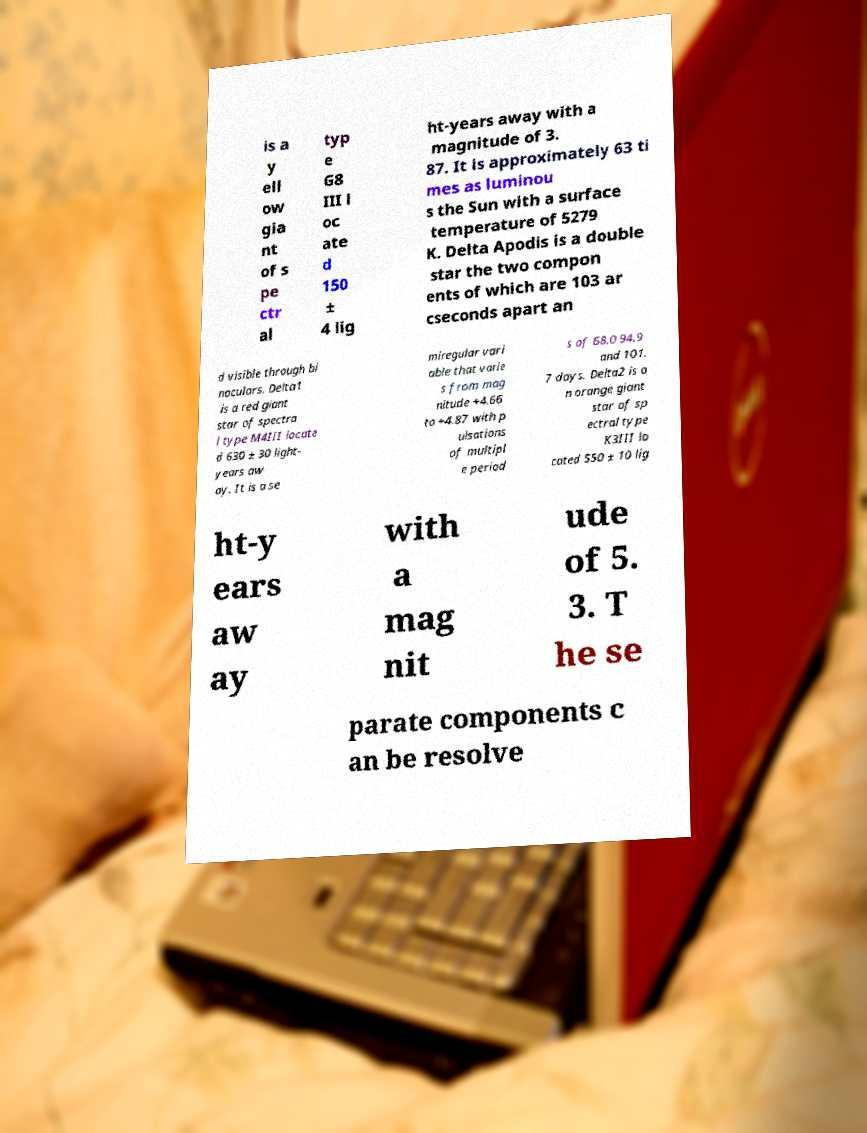There's text embedded in this image that I need extracted. Can you transcribe it verbatim? is a y ell ow gia nt of s pe ctr al typ e G8 III l oc ate d 150 ± 4 lig ht-years away with a magnitude of 3. 87. It is approximately 63 ti mes as luminou s the Sun with a surface temperature of 5279 K. Delta Apodis is a double star the two compon ents of which are 103 ar cseconds apart an d visible through bi noculars. Delta1 is a red giant star of spectra l type M4III locate d 630 ± 30 light- years aw ay. It is a se miregular vari able that varie s from mag nitude +4.66 to +4.87 with p ulsations of multipl e period s of 68.0 94.9 and 101. 7 days. Delta2 is a n orange giant star of sp ectral type K3III lo cated 550 ± 10 lig ht-y ears aw ay with a mag nit ude of 5. 3. T he se parate components c an be resolve 